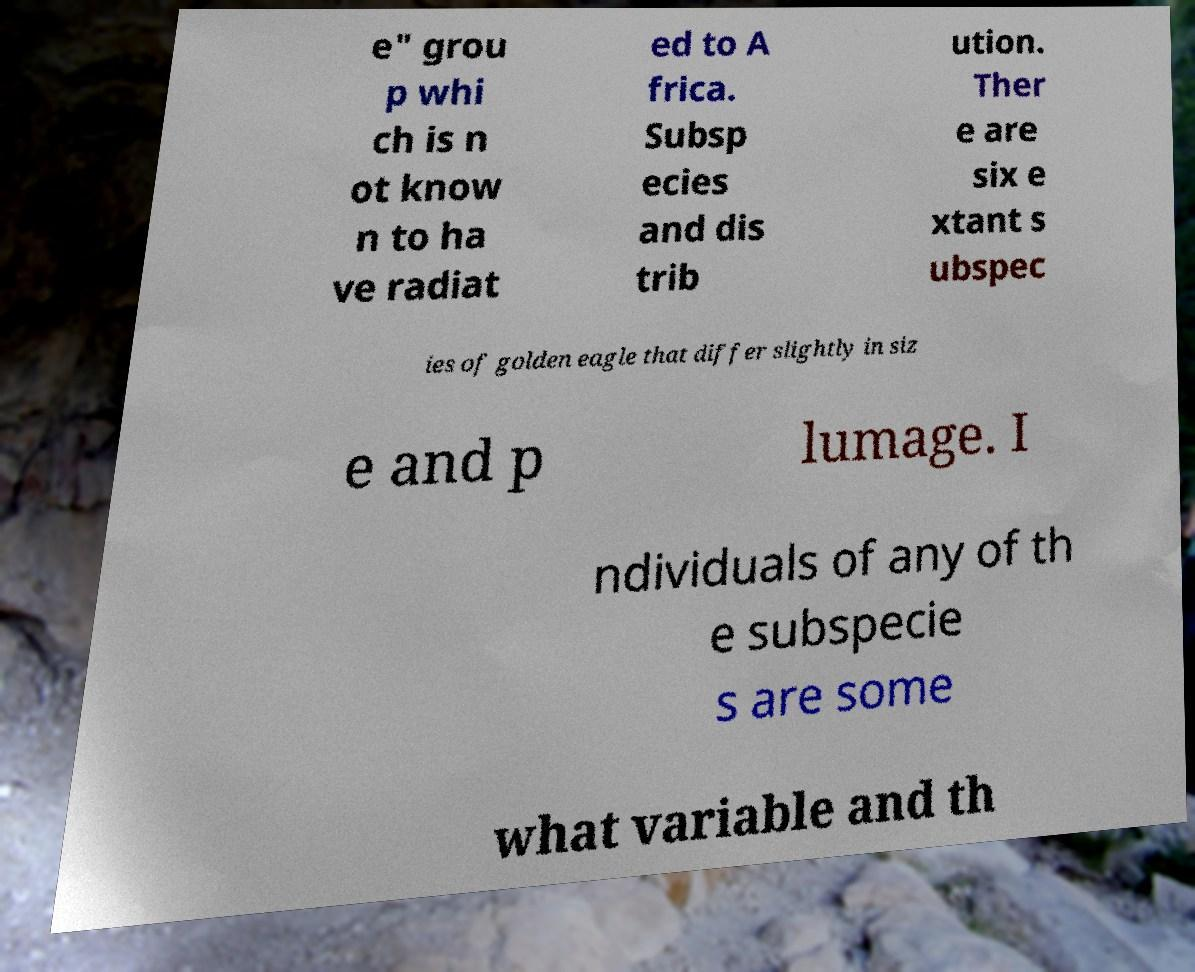I need the written content from this picture converted into text. Can you do that? e" grou p whi ch is n ot know n to ha ve radiat ed to A frica. Subsp ecies and dis trib ution. Ther e are six e xtant s ubspec ies of golden eagle that differ slightly in siz e and p lumage. I ndividuals of any of th e subspecie s are some what variable and th 